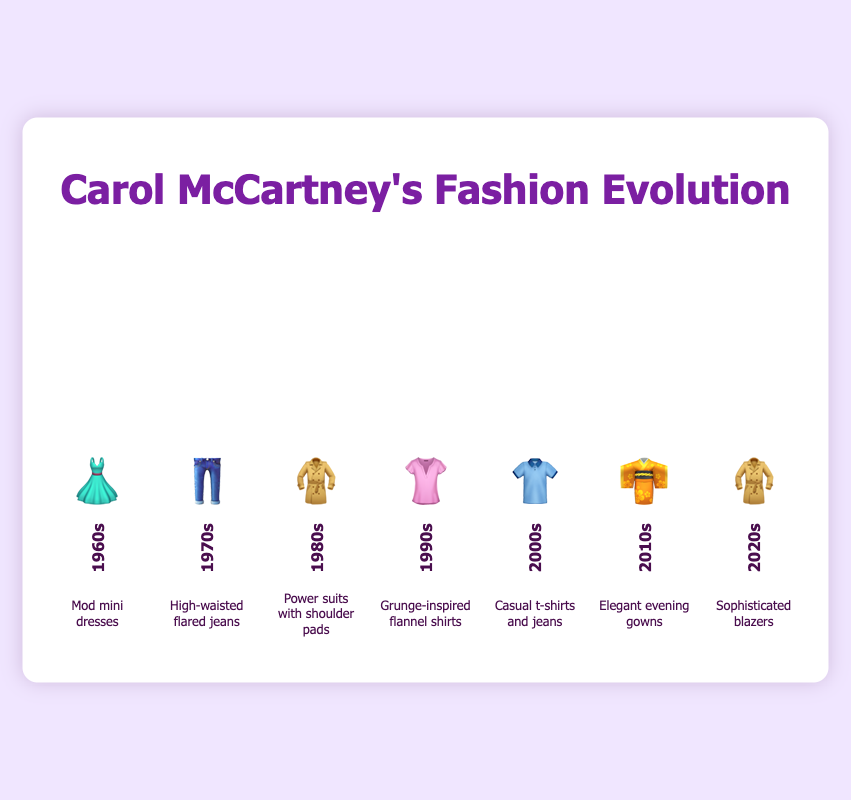What fashion style did Carol McCartney favor in the 1960s? Look for the 1960s decade which has the dress emoji 👗 and the description "Mod mini dresses".
Answer: Mod mini dresses Which decade shows Carol McCartney favoring sophisticated blazers? Check for the decade with the description "Sophisticated blazers" and the blazer emoji 🧥, which is the 2020s.
Answer: 2020s Compare the styles between the 1970s and the 1980s. What are the differences? In the 1970s, Carol's style was "High-waisted flared jeans" represented by the jeans emoji 👖, while in the 1980s, it was "Power suits with shoulder pads" represented by the coat emoji 🧥.
Answer: 1970s: High-waisted flared jeans; 1980s: Power suits with shoulder pads How did Carol McCartney's style change from the 2000s to the 2010s? In the 2000s, Carol favored "Casual t-shirts and jeans" (👕), whereas in the 2010s, her style evolved to "Elegant evening gowns" (👘).
Answer: From casual t-shirts and jeans to elegant evening gowns Which decades have the same emoji representing different fashion styles? The emoji 🧥 appears in both the 1980s and the 2020s, representing "Power suits with shoulder pads" in the 1980s and "Sophisticated blazers" in the 2020s.
Answer: 1980s and 2020s What's the predominant style characteristic of the 1990s era? Look at the 1990s decade which has the shirt emoji 👚 and the description "Grunge-inspired flannel shirts".
Answer: Grunge-inspired flannel shirts List the fashion styles in chronological order starting from the 1960s. Starting from the 1960s to the 2020s, the styles are: "Mod mini dresses" (👗), "High-waisted flared jeans" (👖), "Power suits with shoulder pads" (🧥), "Grunge-inspired flannel shirts" (👚), "Casual t-shirts and jeans" (👕), "Elegant evening gowns" (👘), "Sophisticated blazers" (🧥).
Answer: Mod mini dresses, High-waisted flared jeans, Power suits with shoulder pads, Grunge-inspired flannel shirts, Casual t-shirts and jeans, Elegant evening gowns, Sophisticated blazers In which decade did Carol McCartney favor "Grunge-inspired flannel shirts"? The description "Grunge-inspired flannel shirts" with the emoji 👚 is shown for the 1990s.
Answer: 1990s 